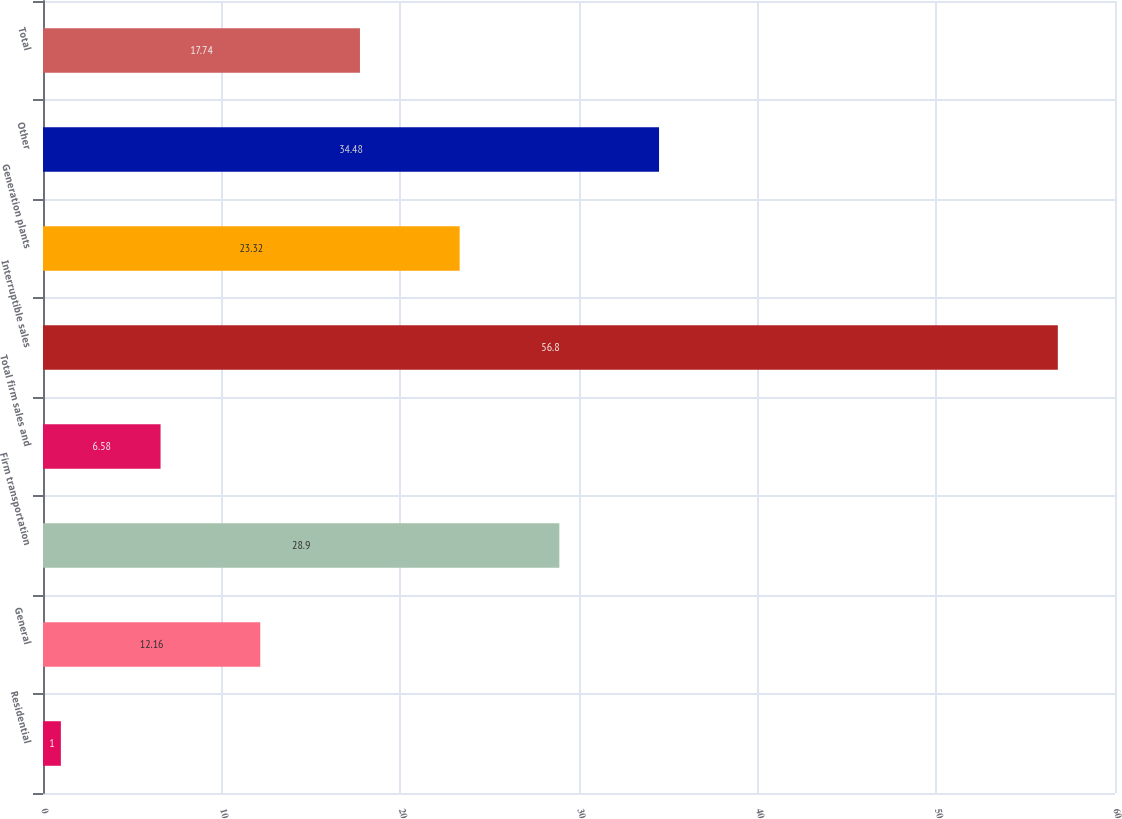Convert chart to OTSL. <chart><loc_0><loc_0><loc_500><loc_500><bar_chart><fcel>Residential<fcel>General<fcel>Firm transportation<fcel>Total firm sales and<fcel>Interruptible sales<fcel>Generation plants<fcel>Other<fcel>Total<nl><fcel>1<fcel>12.16<fcel>28.9<fcel>6.58<fcel>56.8<fcel>23.32<fcel>34.48<fcel>17.74<nl></chart> 